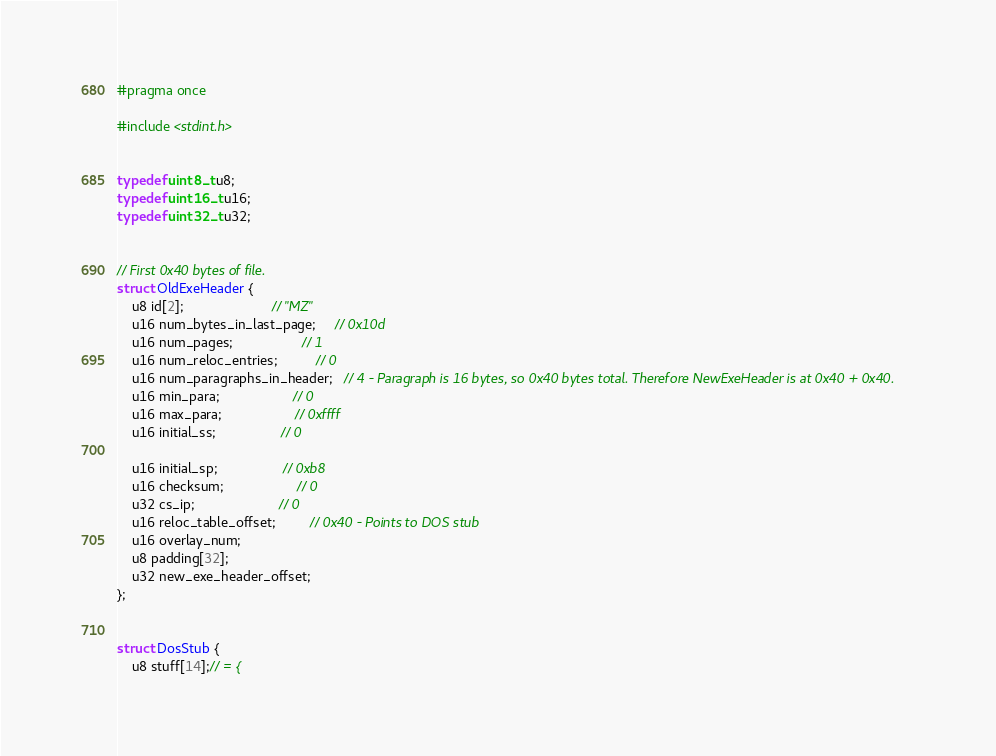<code> <loc_0><loc_0><loc_500><loc_500><_C_>#pragma once

#include <stdint.h>


typedef uint8_t u8;
typedef uint16_t u16;
typedef uint32_t u32;


// First 0x40 bytes of file.
struct OldExeHeader {
    u8 id[2];                       // "MZ"
    u16 num_bytes_in_last_page;     // 0x10d
    u16 num_pages;                  // 1
    u16 num_reloc_entries;          // 0
    u16 num_paragraphs_in_header;   // 4 - Paragraph is 16 bytes, so 0x40 bytes total. Therefore NewExeHeader is at 0x40 + 0x40.
    u16 min_para;                   // 0
    u16 max_para;                   // 0xffff
    u16 initial_ss;                 // 0

    u16 initial_sp;                 // 0xb8
    u16 checksum;                   // 0
    u32 cs_ip;                      // 0
    u16 reloc_table_offset;         // 0x40 - Points to DOS stub
    u16 overlay_num;
    u8 padding[32];
    u32 new_exe_header_offset;
};


struct DosStub {
    u8 stuff[14];// = {</code> 